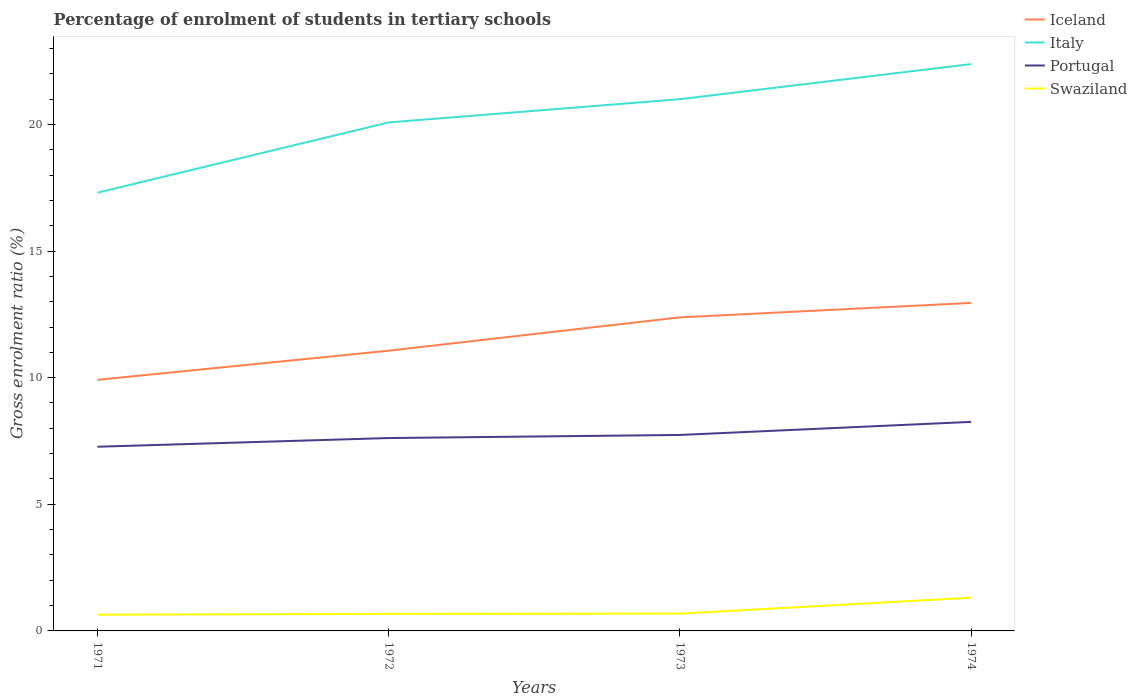How many different coloured lines are there?
Make the answer very short. 4. Is the number of lines equal to the number of legend labels?
Provide a short and direct response. Yes. Across all years, what is the maximum percentage of students enrolled in tertiary schools in Iceland?
Give a very brief answer. 9.91. In which year was the percentage of students enrolled in tertiary schools in Iceland maximum?
Provide a succinct answer. 1971. What is the total percentage of students enrolled in tertiary schools in Portugal in the graph?
Make the answer very short. -0.64. What is the difference between the highest and the second highest percentage of students enrolled in tertiary schools in Swaziland?
Make the answer very short. 0.67. How many years are there in the graph?
Make the answer very short. 4. What is the difference between two consecutive major ticks on the Y-axis?
Keep it short and to the point. 5. Are the values on the major ticks of Y-axis written in scientific E-notation?
Your answer should be very brief. No. Does the graph contain any zero values?
Make the answer very short. No. How are the legend labels stacked?
Ensure brevity in your answer.  Vertical. What is the title of the graph?
Keep it short and to the point. Percentage of enrolment of students in tertiary schools. What is the Gross enrolment ratio (%) in Iceland in 1971?
Give a very brief answer. 9.91. What is the Gross enrolment ratio (%) of Italy in 1971?
Keep it short and to the point. 17.3. What is the Gross enrolment ratio (%) in Portugal in 1971?
Your answer should be very brief. 7.27. What is the Gross enrolment ratio (%) of Swaziland in 1971?
Ensure brevity in your answer.  0.64. What is the Gross enrolment ratio (%) in Iceland in 1972?
Provide a short and direct response. 11.06. What is the Gross enrolment ratio (%) of Italy in 1972?
Offer a very short reply. 20.08. What is the Gross enrolment ratio (%) of Portugal in 1972?
Provide a succinct answer. 7.62. What is the Gross enrolment ratio (%) in Swaziland in 1972?
Your answer should be compact. 0.67. What is the Gross enrolment ratio (%) in Iceland in 1973?
Keep it short and to the point. 12.38. What is the Gross enrolment ratio (%) in Italy in 1973?
Your answer should be compact. 21. What is the Gross enrolment ratio (%) of Portugal in 1973?
Your answer should be compact. 7.74. What is the Gross enrolment ratio (%) in Swaziland in 1973?
Your answer should be compact. 0.68. What is the Gross enrolment ratio (%) of Iceland in 1974?
Offer a very short reply. 12.95. What is the Gross enrolment ratio (%) in Italy in 1974?
Keep it short and to the point. 22.38. What is the Gross enrolment ratio (%) in Portugal in 1974?
Your answer should be very brief. 8.25. What is the Gross enrolment ratio (%) in Swaziland in 1974?
Provide a short and direct response. 1.31. Across all years, what is the maximum Gross enrolment ratio (%) in Iceland?
Keep it short and to the point. 12.95. Across all years, what is the maximum Gross enrolment ratio (%) in Italy?
Make the answer very short. 22.38. Across all years, what is the maximum Gross enrolment ratio (%) of Portugal?
Provide a succinct answer. 8.25. Across all years, what is the maximum Gross enrolment ratio (%) in Swaziland?
Make the answer very short. 1.31. Across all years, what is the minimum Gross enrolment ratio (%) in Iceland?
Provide a succinct answer. 9.91. Across all years, what is the minimum Gross enrolment ratio (%) of Italy?
Ensure brevity in your answer.  17.3. Across all years, what is the minimum Gross enrolment ratio (%) in Portugal?
Your answer should be compact. 7.27. Across all years, what is the minimum Gross enrolment ratio (%) in Swaziland?
Keep it short and to the point. 0.64. What is the total Gross enrolment ratio (%) of Iceland in the graph?
Offer a terse response. 46.31. What is the total Gross enrolment ratio (%) of Italy in the graph?
Offer a very short reply. 80.76. What is the total Gross enrolment ratio (%) in Portugal in the graph?
Your response must be concise. 30.88. What is the total Gross enrolment ratio (%) of Swaziland in the graph?
Give a very brief answer. 3.31. What is the difference between the Gross enrolment ratio (%) of Iceland in 1971 and that in 1972?
Your answer should be very brief. -1.15. What is the difference between the Gross enrolment ratio (%) in Italy in 1971 and that in 1972?
Your answer should be compact. -2.78. What is the difference between the Gross enrolment ratio (%) of Portugal in 1971 and that in 1972?
Your answer should be compact. -0.34. What is the difference between the Gross enrolment ratio (%) of Swaziland in 1971 and that in 1972?
Keep it short and to the point. -0.03. What is the difference between the Gross enrolment ratio (%) of Iceland in 1971 and that in 1973?
Keep it short and to the point. -2.47. What is the difference between the Gross enrolment ratio (%) of Italy in 1971 and that in 1973?
Make the answer very short. -3.69. What is the difference between the Gross enrolment ratio (%) of Portugal in 1971 and that in 1973?
Offer a terse response. -0.47. What is the difference between the Gross enrolment ratio (%) in Swaziland in 1971 and that in 1973?
Give a very brief answer. -0.04. What is the difference between the Gross enrolment ratio (%) in Iceland in 1971 and that in 1974?
Provide a short and direct response. -3.04. What is the difference between the Gross enrolment ratio (%) of Italy in 1971 and that in 1974?
Provide a short and direct response. -5.08. What is the difference between the Gross enrolment ratio (%) in Portugal in 1971 and that in 1974?
Offer a terse response. -0.98. What is the difference between the Gross enrolment ratio (%) in Swaziland in 1971 and that in 1974?
Make the answer very short. -0.67. What is the difference between the Gross enrolment ratio (%) in Iceland in 1972 and that in 1973?
Give a very brief answer. -1.32. What is the difference between the Gross enrolment ratio (%) of Italy in 1972 and that in 1973?
Give a very brief answer. -0.92. What is the difference between the Gross enrolment ratio (%) of Portugal in 1972 and that in 1973?
Offer a terse response. -0.12. What is the difference between the Gross enrolment ratio (%) of Swaziland in 1972 and that in 1973?
Provide a succinct answer. -0.01. What is the difference between the Gross enrolment ratio (%) of Iceland in 1972 and that in 1974?
Offer a terse response. -1.89. What is the difference between the Gross enrolment ratio (%) of Italy in 1972 and that in 1974?
Offer a very short reply. -2.3. What is the difference between the Gross enrolment ratio (%) in Portugal in 1972 and that in 1974?
Offer a terse response. -0.64. What is the difference between the Gross enrolment ratio (%) in Swaziland in 1972 and that in 1974?
Keep it short and to the point. -0.64. What is the difference between the Gross enrolment ratio (%) of Iceland in 1973 and that in 1974?
Your response must be concise. -0.57. What is the difference between the Gross enrolment ratio (%) in Italy in 1973 and that in 1974?
Your answer should be very brief. -1.39. What is the difference between the Gross enrolment ratio (%) of Portugal in 1973 and that in 1974?
Provide a short and direct response. -0.52. What is the difference between the Gross enrolment ratio (%) of Swaziland in 1973 and that in 1974?
Give a very brief answer. -0.63. What is the difference between the Gross enrolment ratio (%) of Iceland in 1971 and the Gross enrolment ratio (%) of Italy in 1972?
Offer a very short reply. -10.16. What is the difference between the Gross enrolment ratio (%) in Iceland in 1971 and the Gross enrolment ratio (%) in Portugal in 1972?
Keep it short and to the point. 2.3. What is the difference between the Gross enrolment ratio (%) of Iceland in 1971 and the Gross enrolment ratio (%) of Swaziland in 1972?
Your answer should be compact. 9.24. What is the difference between the Gross enrolment ratio (%) of Italy in 1971 and the Gross enrolment ratio (%) of Portugal in 1972?
Provide a short and direct response. 9.69. What is the difference between the Gross enrolment ratio (%) in Italy in 1971 and the Gross enrolment ratio (%) in Swaziland in 1972?
Give a very brief answer. 16.63. What is the difference between the Gross enrolment ratio (%) of Portugal in 1971 and the Gross enrolment ratio (%) of Swaziland in 1972?
Provide a succinct answer. 6.6. What is the difference between the Gross enrolment ratio (%) in Iceland in 1971 and the Gross enrolment ratio (%) in Italy in 1973?
Keep it short and to the point. -11.08. What is the difference between the Gross enrolment ratio (%) in Iceland in 1971 and the Gross enrolment ratio (%) in Portugal in 1973?
Provide a short and direct response. 2.18. What is the difference between the Gross enrolment ratio (%) in Iceland in 1971 and the Gross enrolment ratio (%) in Swaziland in 1973?
Ensure brevity in your answer.  9.23. What is the difference between the Gross enrolment ratio (%) in Italy in 1971 and the Gross enrolment ratio (%) in Portugal in 1973?
Provide a short and direct response. 9.56. What is the difference between the Gross enrolment ratio (%) of Italy in 1971 and the Gross enrolment ratio (%) of Swaziland in 1973?
Give a very brief answer. 16.62. What is the difference between the Gross enrolment ratio (%) of Portugal in 1971 and the Gross enrolment ratio (%) of Swaziland in 1973?
Give a very brief answer. 6.59. What is the difference between the Gross enrolment ratio (%) in Iceland in 1971 and the Gross enrolment ratio (%) in Italy in 1974?
Give a very brief answer. -12.47. What is the difference between the Gross enrolment ratio (%) in Iceland in 1971 and the Gross enrolment ratio (%) in Portugal in 1974?
Your answer should be compact. 1.66. What is the difference between the Gross enrolment ratio (%) in Iceland in 1971 and the Gross enrolment ratio (%) in Swaziland in 1974?
Keep it short and to the point. 8.6. What is the difference between the Gross enrolment ratio (%) in Italy in 1971 and the Gross enrolment ratio (%) in Portugal in 1974?
Give a very brief answer. 9.05. What is the difference between the Gross enrolment ratio (%) of Italy in 1971 and the Gross enrolment ratio (%) of Swaziland in 1974?
Provide a short and direct response. 15.99. What is the difference between the Gross enrolment ratio (%) of Portugal in 1971 and the Gross enrolment ratio (%) of Swaziland in 1974?
Offer a very short reply. 5.96. What is the difference between the Gross enrolment ratio (%) in Iceland in 1972 and the Gross enrolment ratio (%) in Italy in 1973?
Make the answer very short. -9.93. What is the difference between the Gross enrolment ratio (%) in Iceland in 1972 and the Gross enrolment ratio (%) in Portugal in 1973?
Keep it short and to the point. 3.33. What is the difference between the Gross enrolment ratio (%) in Iceland in 1972 and the Gross enrolment ratio (%) in Swaziland in 1973?
Ensure brevity in your answer.  10.38. What is the difference between the Gross enrolment ratio (%) of Italy in 1972 and the Gross enrolment ratio (%) of Portugal in 1973?
Provide a succinct answer. 12.34. What is the difference between the Gross enrolment ratio (%) in Italy in 1972 and the Gross enrolment ratio (%) in Swaziland in 1973?
Offer a very short reply. 19.4. What is the difference between the Gross enrolment ratio (%) in Portugal in 1972 and the Gross enrolment ratio (%) in Swaziland in 1973?
Offer a terse response. 6.93. What is the difference between the Gross enrolment ratio (%) of Iceland in 1972 and the Gross enrolment ratio (%) of Italy in 1974?
Offer a very short reply. -11.32. What is the difference between the Gross enrolment ratio (%) of Iceland in 1972 and the Gross enrolment ratio (%) of Portugal in 1974?
Keep it short and to the point. 2.81. What is the difference between the Gross enrolment ratio (%) in Iceland in 1972 and the Gross enrolment ratio (%) in Swaziland in 1974?
Keep it short and to the point. 9.75. What is the difference between the Gross enrolment ratio (%) in Italy in 1972 and the Gross enrolment ratio (%) in Portugal in 1974?
Your answer should be very brief. 11.82. What is the difference between the Gross enrolment ratio (%) of Italy in 1972 and the Gross enrolment ratio (%) of Swaziland in 1974?
Provide a short and direct response. 18.77. What is the difference between the Gross enrolment ratio (%) of Portugal in 1972 and the Gross enrolment ratio (%) of Swaziland in 1974?
Give a very brief answer. 6.3. What is the difference between the Gross enrolment ratio (%) of Iceland in 1973 and the Gross enrolment ratio (%) of Italy in 1974?
Provide a short and direct response. -10. What is the difference between the Gross enrolment ratio (%) of Iceland in 1973 and the Gross enrolment ratio (%) of Portugal in 1974?
Offer a very short reply. 4.13. What is the difference between the Gross enrolment ratio (%) of Iceland in 1973 and the Gross enrolment ratio (%) of Swaziland in 1974?
Make the answer very short. 11.07. What is the difference between the Gross enrolment ratio (%) in Italy in 1973 and the Gross enrolment ratio (%) in Portugal in 1974?
Your answer should be compact. 12.74. What is the difference between the Gross enrolment ratio (%) of Italy in 1973 and the Gross enrolment ratio (%) of Swaziland in 1974?
Offer a terse response. 19.68. What is the difference between the Gross enrolment ratio (%) of Portugal in 1973 and the Gross enrolment ratio (%) of Swaziland in 1974?
Offer a terse response. 6.43. What is the average Gross enrolment ratio (%) in Iceland per year?
Keep it short and to the point. 11.58. What is the average Gross enrolment ratio (%) of Italy per year?
Your answer should be compact. 20.19. What is the average Gross enrolment ratio (%) in Portugal per year?
Offer a terse response. 7.72. What is the average Gross enrolment ratio (%) of Swaziland per year?
Your answer should be very brief. 0.83. In the year 1971, what is the difference between the Gross enrolment ratio (%) in Iceland and Gross enrolment ratio (%) in Italy?
Your answer should be very brief. -7.39. In the year 1971, what is the difference between the Gross enrolment ratio (%) of Iceland and Gross enrolment ratio (%) of Portugal?
Give a very brief answer. 2.64. In the year 1971, what is the difference between the Gross enrolment ratio (%) in Iceland and Gross enrolment ratio (%) in Swaziland?
Ensure brevity in your answer.  9.27. In the year 1971, what is the difference between the Gross enrolment ratio (%) of Italy and Gross enrolment ratio (%) of Portugal?
Ensure brevity in your answer.  10.03. In the year 1971, what is the difference between the Gross enrolment ratio (%) in Italy and Gross enrolment ratio (%) in Swaziland?
Keep it short and to the point. 16.66. In the year 1971, what is the difference between the Gross enrolment ratio (%) of Portugal and Gross enrolment ratio (%) of Swaziland?
Offer a terse response. 6.63. In the year 1972, what is the difference between the Gross enrolment ratio (%) in Iceland and Gross enrolment ratio (%) in Italy?
Offer a terse response. -9.01. In the year 1972, what is the difference between the Gross enrolment ratio (%) in Iceland and Gross enrolment ratio (%) in Portugal?
Provide a succinct answer. 3.45. In the year 1972, what is the difference between the Gross enrolment ratio (%) in Iceland and Gross enrolment ratio (%) in Swaziland?
Provide a short and direct response. 10.39. In the year 1972, what is the difference between the Gross enrolment ratio (%) in Italy and Gross enrolment ratio (%) in Portugal?
Ensure brevity in your answer.  12.46. In the year 1972, what is the difference between the Gross enrolment ratio (%) in Italy and Gross enrolment ratio (%) in Swaziland?
Make the answer very short. 19.41. In the year 1972, what is the difference between the Gross enrolment ratio (%) of Portugal and Gross enrolment ratio (%) of Swaziland?
Ensure brevity in your answer.  6.94. In the year 1973, what is the difference between the Gross enrolment ratio (%) of Iceland and Gross enrolment ratio (%) of Italy?
Keep it short and to the point. -8.61. In the year 1973, what is the difference between the Gross enrolment ratio (%) in Iceland and Gross enrolment ratio (%) in Portugal?
Give a very brief answer. 4.64. In the year 1973, what is the difference between the Gross enrolment ratio (%) of Iceland and Gross enrolment ratio (%) of Swaziland?
Provide a succinct answer. 11.7. In the year 1973, what is the difference between the Gross enrolment ratio (%) in Italy and Gross enrolment ratio (%) in Portugal?
Make the answer very short. 13.26. In the year 1973, what is the difference between the Gross enrolment ratio (%) in Italy and Gross enrolment ratio (%) in Swaziland?
Your answer should be compact. 20.31. In the year 1973, what is the difference between the Gross enrolment ratio (%) in Portugal and Gross enrolment ratio (%) in Swaziland?
Ensure brevity in your answer.  7.05. In the year 1974, what is the difference between the Gross enrolment ratio (%) in Iceland and Gross enrolment ratio (%) in Italy?
Make the answer very short. -9.43. In the year 1974, what is the difference between the Gross enrolment ratio (%) in Iceland and Gross enrolment ratio (%) in Portugal?
Offer a very short reply. 4.7. In the year 1974, what is the difference between the Gross enrolment ratio (%) in Iceland and Gross enrolment ratio (%) in Swaziland?
Make the answer very short. 11.64. In the year 1974, what is the difference between the Gross enrolment ratio (%) of Italy and Gross enrolment ratio (%) of Portugal?
Give a very brief answer. 14.13. In the year 1974, what is the difference between the Gross enrolment ratio (%) in Italy and Gross enrolment ratio (%) in Swaziland?
Your answer should be compact. 21.07. In the year 1974, what is the difference between the Gross enrolment ratio (%) of Portugal and Gross enrolment ratio (%) of Swaziland?
Offer a terse response. 6.94. What is the ratio of the Gross enrolment ratio (%) in Iceland in 1971 to that in 1972?
Provide a succinct answer. 0.9. What is the ratio of the Gross enrolment ratio (%) of Italy in 1971 to that in 1972?
Ensure brevity in your answer.  0.86. What is the ratio of the Gross enrolment ratio (%) in Portugal in 1971 to that in 1972?
Offer a very short reply. 0.95. What is the ratio of the Gross enrolment ratio (%) in Swaziland in 1971 to that in 1972?
Offer a very short reply. 0.95. What is the ratio of the Gross enrolment ratio (%) of Iceland in 1971 to that in 1973?
Give a very brief answer. 0.8. What is the ratio of the Gross enrolment ratio (%) of Italy in 1971 to that in 1973?
Ensure brevity in your answer.  0.82. What is the ratio of the Gross enrolment ratio (%) of Portugal in 1971 to that in 1973?
Offer a very short reply. 0.94. What is the ratio of the Gross enrolment ratio (%) of Swaziland in 1971 to that in 1973?
Give a very brief answer. 0.94. What is the ratio of the Gross enrolment ratio (%) in Iceland in 1971 to that in 1974?
Offer a very short reply. 0.77. What is the ratio of the Gross enrolment ratio (%) of Italy in 1971 to that in 1974?
Keep it short and to the point. 0.77. What is the ratio of the Gross enrolment ratio (%) in Portugal in 1971 to that in 1974?
Your answer should be compact. 0.88. What is the ratio of the Gross enrolment ratio (%) in Swaziland in 1971 to that in 1974?
Offer a terse response. 0.49. What is the ratio of the Gross enrolment ratio (%) in Iceland in 1972 to that in 1973?
Make the answer very short. 0.89. What is the ratio of the Gross enrolment ratio (%) in Italy in 1972 to that in 1973?
Your answer should be very brief. 0.96. What is the ratio of the Gross enrolment ratio (%) of Portugal in 1972 to that in 1973?
Offer a terse response. 0.98. What is the ratio of the Gross enrolment ratio (%) in Swaziland in 1972 to that in 1973?
Your answer should be very brief. 0.98. What is the ratio of the Gross enrolment ratio (%) of Iceland in 1972 to that in 1974?
Offer a terse response. 0.85. What is the ratio of the Gross enrolment ratio (%) of Italy in 1972 to that in 1974?
Give a very brief answer. 0.9. What is the ratio of the Gross enrolment ratio (%) in Portugal in 1972 to that in 1974?
Your answer should be very brief. 0.92. What is the ratio of the Gross enrolment ratio (%) in Swaziland in 1972 to that in 1974?
Make the answer very short. 0.51. What is the ratio of the Gross enrolment ratio (%) in Iceland in 1973 to that in 1974?
Provide a short and direct response. 0.96. What is the ratio of the Gross enrolment ratio (%) of Italy in 1973 to that in 1974?
Provide a succinct answer. 0.94. What is the ratio of the Gross enrolment ratio (%) in Portugal in 1973 to that in 1974?
Ensure brevity in your answer.  0.94. What is the ratio of the Gross enrolment ratio (%) in Swaziland in 1973 to that in 1974?
Give a very brief answer. 0.52. What is the difference between the highest and the second highest Gross enrolment ratio (%) of Iceland?
Make the answer very short. 0.57. What is the difference between the highest and the second highest Gross enrolment ratio (%) of Italy?
Give a very brief answer. 1.39. What is the difference between the highest and the second highest Gross enrolment ratio (%) of Portugal?
Your answer should be compact. 0.52. What is the difference between the highest and the second highest Gross enrolment ratio (%) in Swaziland?
Offer a very short reply. 0.63. What is the difference between the highest and the lowest Gross enrolment ratio (%) in Iceland?
Ensure brevity in your answer.  3.04. What is the difference between the highest and the lowest Gross enrolment ratio (%) of Italy?
Offer a very short reply. 5.08. What is the difference between the highest and the lowest Gross enrolment ratio (%) of Portugal?
Provide a short and direct response. 0.98. What is the difference between the highest and the lowest Gross enrolment ratio (%) of Swaziland?
Your response must be concise. 0.67. 